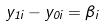Convert formula to latex. <formula><loc_0><loc_0><loc_500><loc_500>y _ { 1 i } - y _ { 0 i } = \beta _ { i }</formula> 